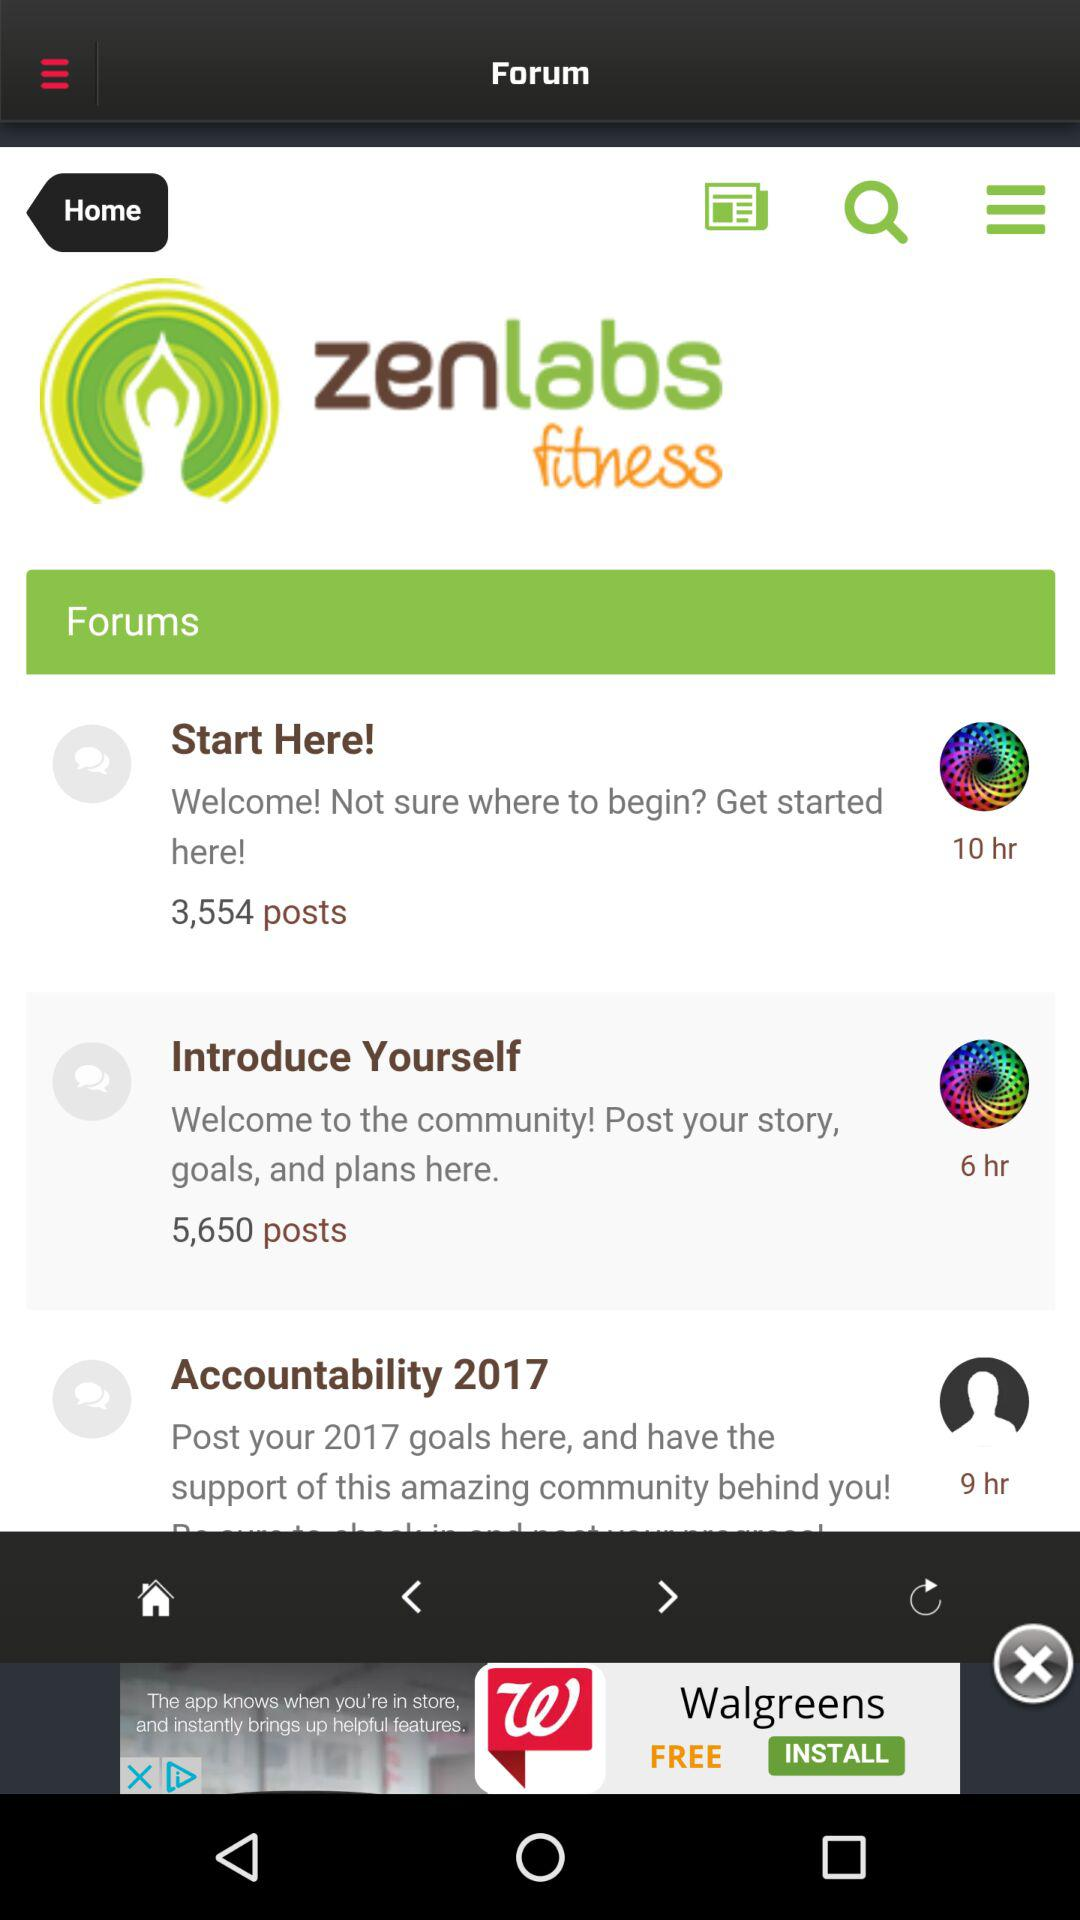What is the number of posts in the segment "Start Here"? The number of posts is 3,554. 